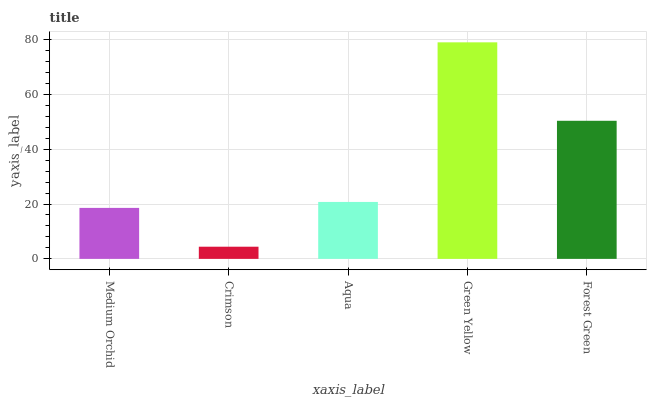Is Crimson the minimum?
Answer yes or no. Yes. Is Green Yellow the maximum?
Answer yes or no. Yes. Is Aqua the minimum?
Answer yes or no. No. Is Aqua the maximum?
Answer yes or no. No. Is Aqua greater than Crimson?
Answer yes or no. Yes. Is Crimson less than Aqua?
Answer yes or no. Yes. Is Crimson greater than Aqua?
Answer yes or no. No. Is Aqua less than Crimson?
Answer yes or no. No. Is Aqua the high median?
Answer yes or no. Yes. Is Aqua the low median?
Answer yes or no. Yes. Is Medium Orchid the high median?
Answer yes or no. No. Is Medium Orchid the low median?
Answer yes or no. No. 